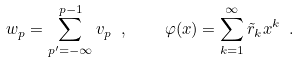Convert formula to latex. <formula><loc_0><loc_0><loc_500><loc_500>w _ { p } = \sum _ { p ^ { \prime } = - \infty } ^ { p - 1 } v _ { p } \ , \quad \varphi ( x ) = \sum _ { k = 1 } ^ { \infty } \tilde { r } _ { k } x ^ { k } \ .</formula> 